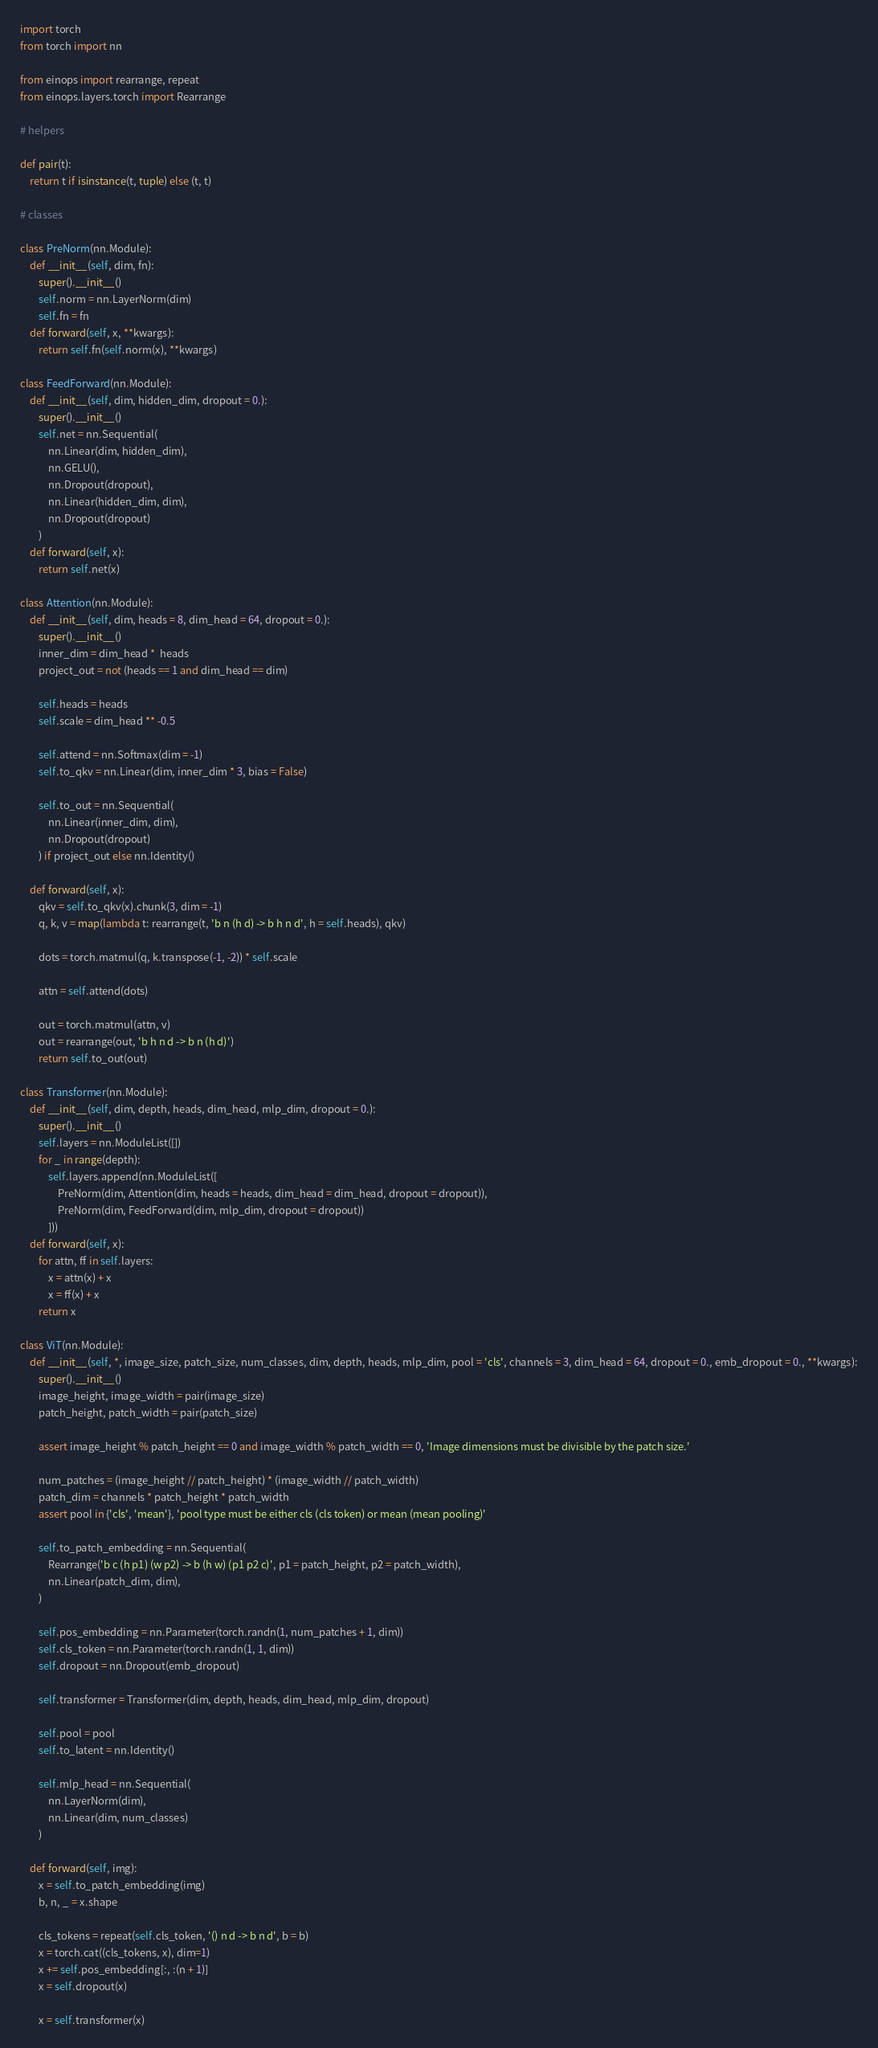Convert code to text. <code><loc_0><loc_0><loc_500><loc_500><_Python_>import torch
from torch import nn

from einops import rearrange, repeat
from einops.layers.torch import Rearrange

# helpers

def pair(t):
    return t if isinstance(t, tuple) else (t, t)

# classes

class PreNorm(nn.Module):
    def __init__(self, dim, fn):
        super().__init__()
        self.norm = nn.LayerNorm(dim)
        self.fn = fn
    def forward(self, x, **kwargs):
        return self.fn(self.norm(x), **kwargs)

class FeedForward(nn.Module):
    def __init__(self, dim, hidden_dim, dropout = 0.):
        super().__init__()
        self.net = nn.Sequential(
            nn.Linear(dim, hidden_dim),
            nn.GELU(),
            nn.Dropout(dropout),
            nn.Linear(hidden_dim, dim),
            nn.Dropout(dropout)
        )
    def forward(self, x):
        return self.net(x)

class Attention(nn.Module):
    def __init__(self, dim, heads = 8, dim_head = 64, dropout = 0.):
        super().__init__()
        inner_dim = dim_head *  heads
        project_out = not (heads == 1 and dim_head == dim)

        self.heads = heads
        self.scale = dim_head ** -0.5

        self.attend = nn.Softmax(dim = -1)
        self.to_qkv = nn.Linear(dim, inner_dim * 3, bias = False)

        self.to_out = nn.Sequential(
            nn.Linear(inner_dim, dim),
            nn.Dropout(dropout)
        ) if project_out else nn.Identity()

    def forward(self, x):
        qkv = self.to_qkv(x).chunk(3, dim = -1)
        q, k, v = map(lambda t: rearrange(t, 'b n (h d) -> b h n d', h = self.heads), qkv)

        dots = torch.matmul(q, k.transpose(-1, -2)) * self.scale

        attn = self.attend(dots)

        out = torch.matmul(attn, v)
        out = rearrange(out, 'b h n d -> b n (h d)')
        return self.to_out(out)

class Transformer(nn.Module):
    def __init__(self, dim, depth, heads, dim_head, mlp_dim, dropout = 0.):
        super().__init__()
        self.layers = nn.ModuleList([])
        for _ in range(depth):
            self.layers.append(nn.ModuleList([
                PreNorm(dim, Attention(dim, heads = heads, dim_head = dim_head, dropout = dropout)),
                PreNorm(dim, FeedForward(dim, mlp_dim, dropout = dropout))
            ]))
    def forward(self, x):
        for attn, ff in self.layers:
            x = attn(x) + x
            x = ff(x) + x
        return x

class ViT(nn.Module):
    def __init__(self, *, image_size, patch_size, num_classes, dim, depth, heads, mlp_dim, pool = 'cls', channels = 3, dim_head = 64, dropout = 0., emb_dropout = 0., **kwargs):
        super().__init__()
        image_height, image_width = pair(image_size)
        patch_height, patch_width = pair(patch_size)

        assert image_height % patch_height == 0 and image_width % patch_width == 0, 'Image dimensions must be divisible by the patch size.'

        num_patches = (image_height // patch_height) * (image_width // patch_width)
        patch_dim = channels * patch_height * patch_width
        assert pool in {'cls', 'mean'}, 'pool type must be either cls (cls token) or mean (mean pooling)'

        self.to_patch_embedding = nn.Sequential(
            Rearrange('b c (h p1) (w p2) -> b (h w) (p1 p2 c)', p1 = patch_height, p2 = patch_width),
            nn.Linear(patch_dim, dim),
        )

        self.pos_embedding = nn.Parameter(torch.randn(1, num_patches + 1, dim))
        self.cls_token = nn.Parameter(torch.randn(1, 1, dim))
        self.dropout = nn.Dropout(emb_dropout)

        self.transformer = Transformer(dim, depth, heads, dim_head, mlp_dim, dropout)

        self.pool = pool
        self.to_latent = nn.Identity()

        self.mlp_head = nn.Sequential(
            nn.LayerNorm(dim),
            nn.Linear(dim, num_classes)
        )

    def forward(self, img):
        x = self.to_patch_embedding(img)
        b, n, _ = x.shape

        cls_tokens = repeat(self.cls_token, '() n d -> b n d', b = b)
        x = torch.cat((cls_tokens, x), dim=1)
        x += self.pos_embedding[:, :(n + 1)]
        x = self.dropout(x)

        x = self.transformer(x)
</code> 